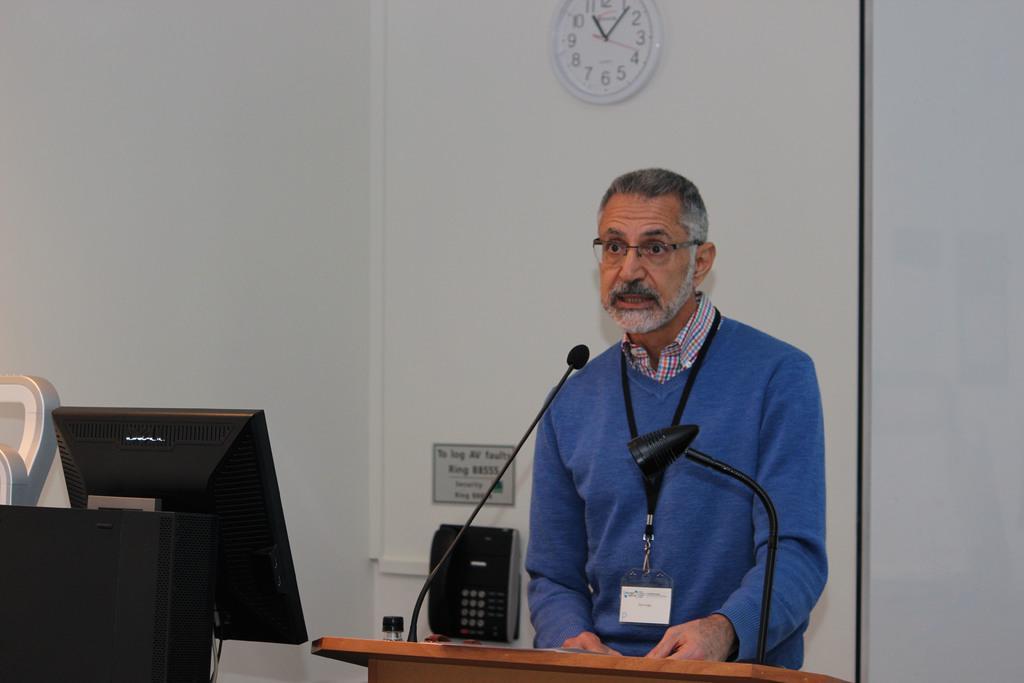Could you give a brief overview of what you see in this image? In the center of the image we can see one person is standing and he is in a different costume. In front of him, we can see a wooden object. On that object, we can see a microphone and some objects. On the left side of the image we can see a monitor and some objects. In the background there is a wall, wall clock, paper with some text and a landline phone. 